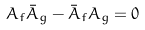Convert formula to latex. <formula><loc_0><loc_0><loc_500><loc_500>A _ { f } \bar { A } _ { g } - \bar { A } _ { f } A _ { g } = 0</formula> 